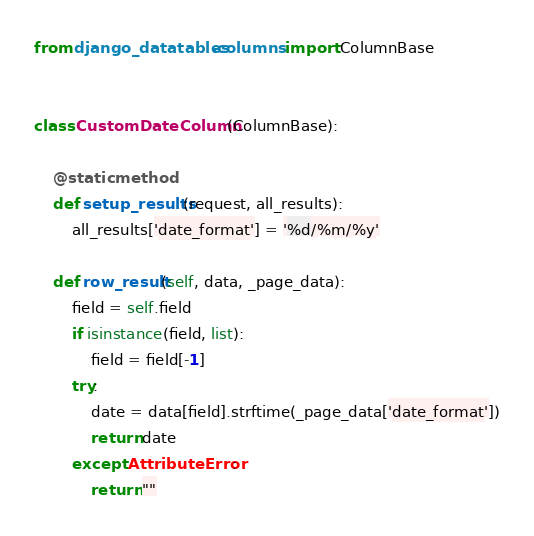Convert code to text. <code><loc_0><loc_0><loc_500><loc_500><_Python_>from django_datatables.columns import ColumnBase


class CustomDateColumn(ColumnBase):

    @staticmethod
    def setup_results(request, all_results):
        all_results['date_format'] = '%d/%m/%y'

    def row_result(self, data, _page_data):
        field = self.field
        if isinstance(field, list):
            field = field[-1]
        try:
            date = data[field].strftime(_page_data['date_format'])
            return date
        except AttributeError:
            return ""
</code> 